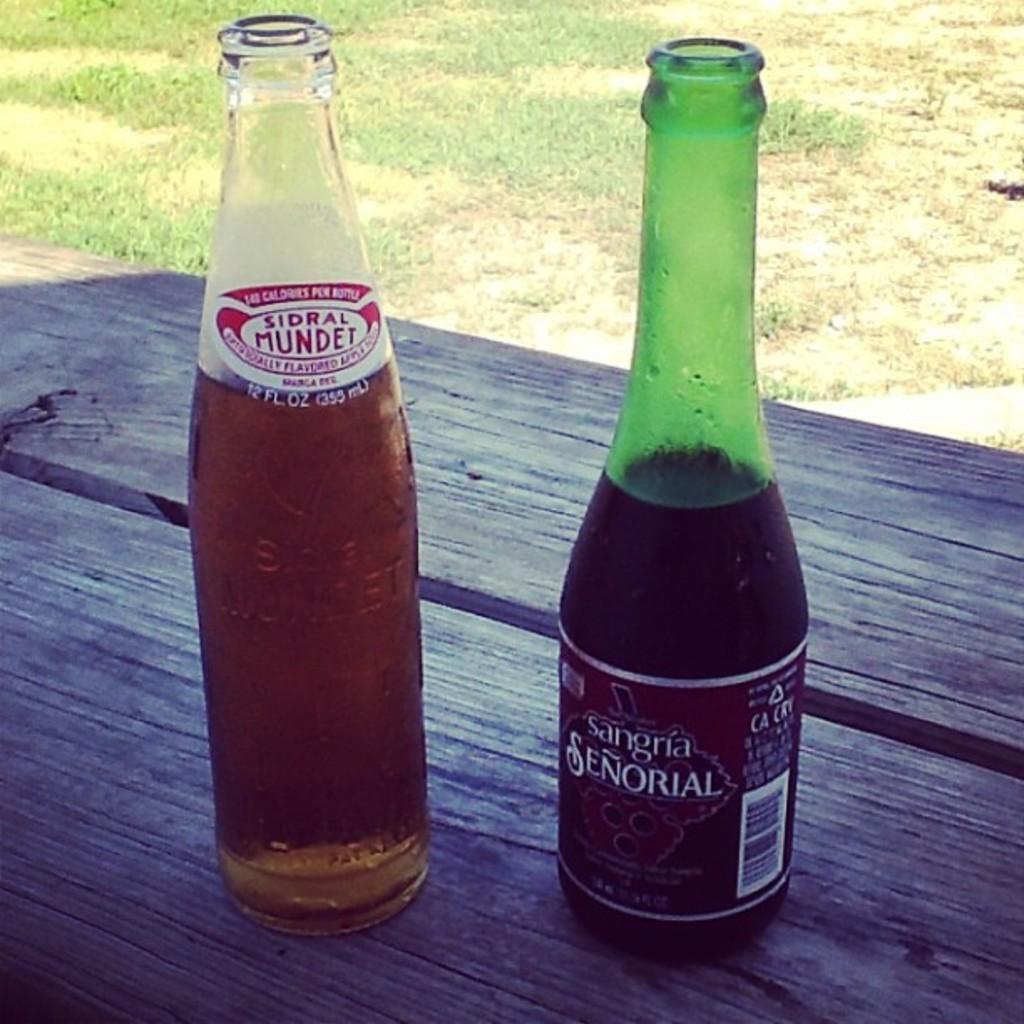What type of beverage is in the bottle on the left?
Keep it short and to the point. Sidral mundet. How many fluid ounces are listed on the bottle on the left?
Ensure brevity in your answer.  12. 